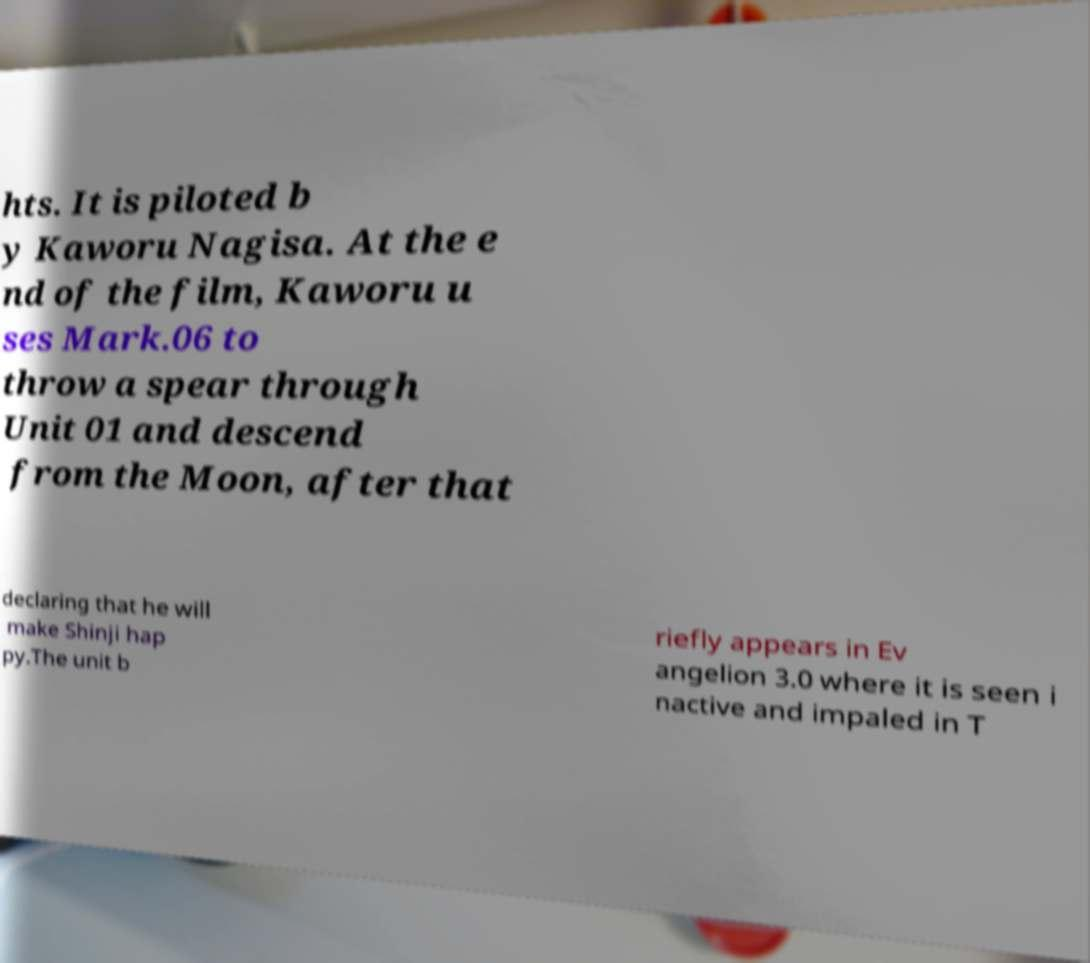Can you accurately transcribe the text from the provided image for me? hts. It is piloted b y Kaworu Nagisa. At the e nd of the film, Kaworu u ses Mark.06 to throw a spear through Unit 01 and descend from the Moon, after that declaring that he will make Shinji hap py.The unit b riefly appears in Ev angelion 3.0 where it is seen i nactive and impaled in T 